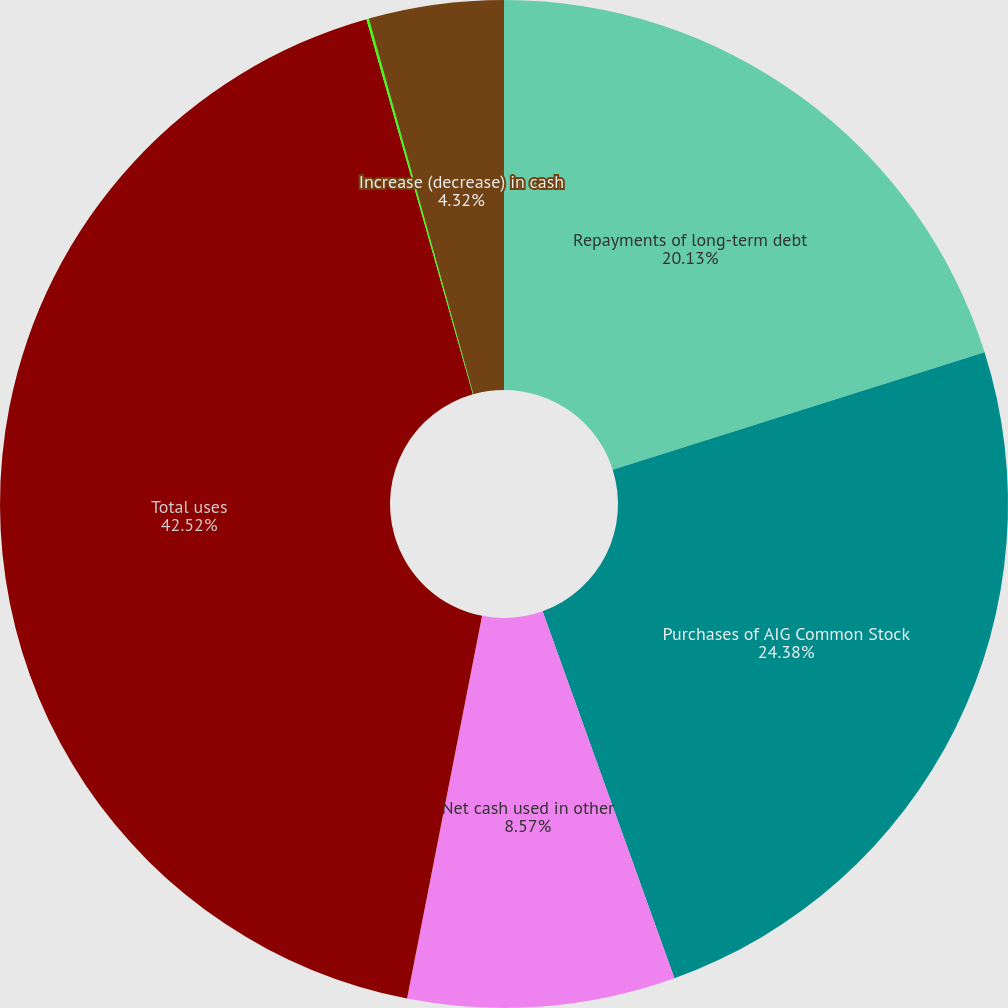Convert chart to OTSL. <chart><loc_0><loc_0><loc_500><loc_500><pie_chart><fcel>Repayments of long-term debt<fcel>Purchases of AIG Common Stock<fcel>Net cash used in other<fcel>Total uses<fcel>Effect of exchange rate<fcel>Increase (decrease) in cash<nl><fcel>20.13%<fcel>24.38%<fcel>8.57%<fcel>42.52%<fcel>0.08%<fcel>4.32%<nl></chart> 